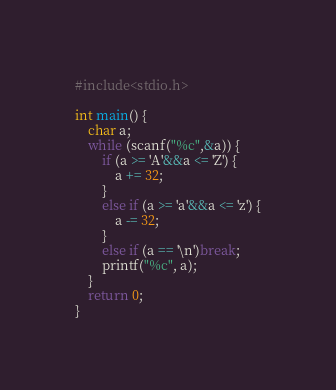Convert code to text. <code><loc_0><loc_0><loc_500><loc_500><_C++_>#include<stdio.h>

int main() {
	char a;
	while (scanf("%c",&a)) {
		if (a >= 'A'&&a <= 'Z') {
			a += 32;
		}
		else if (a >= 'a'&&a <= 'z') {
			a -= 32;
		}
		else if (a == '\n')break;
		printf("%c", a);
	}
	return 0;
}
</code> 